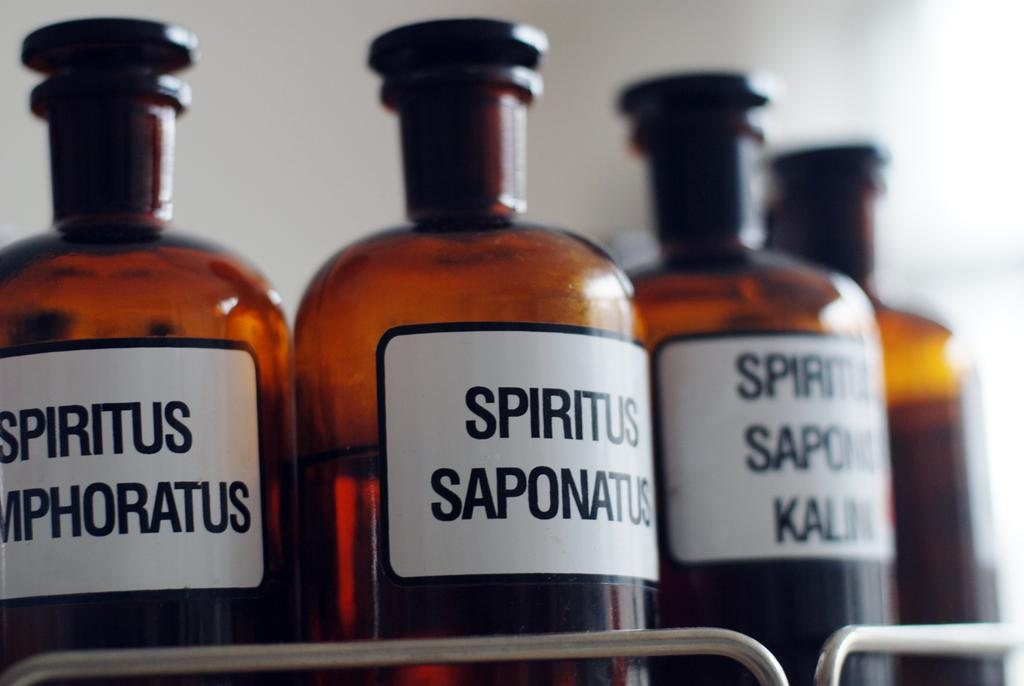Provide a one-sentence caption for the provided image. Many bottles of Spiritus Saponatus are next to each other. 